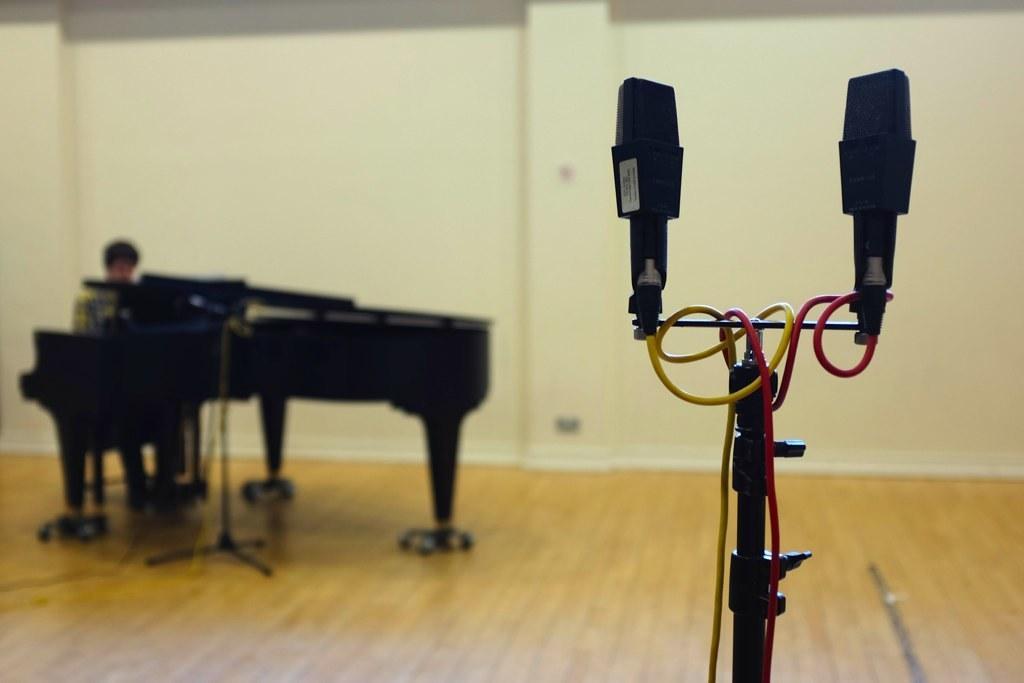Please provide a concise description of this image. In this image, There is a floor which is in yellow color and in the right side there is a microphone which is in black color and in the left side there is a piano which is in black color, In the background there is a wall in white color. 